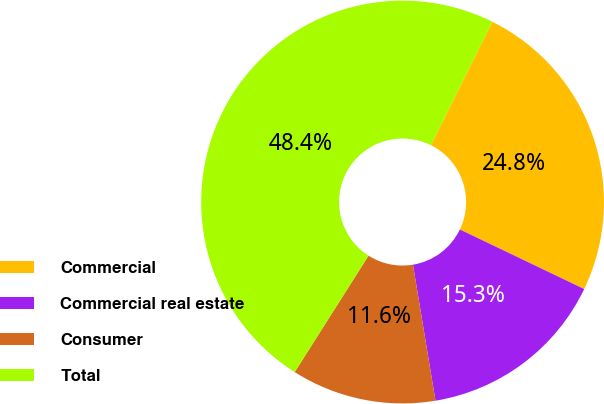Convert chart. <chart><loc_0><loc_0><loc_500><loc_500><pie_chart><fcel>Commercial<fcel>Commercial real estate<fcel>Consumer<fcel>Total<nl><fcel>24.76%<fcel>15.28%<fcel>11.61%<fcel>48.36%<nl></chart> 